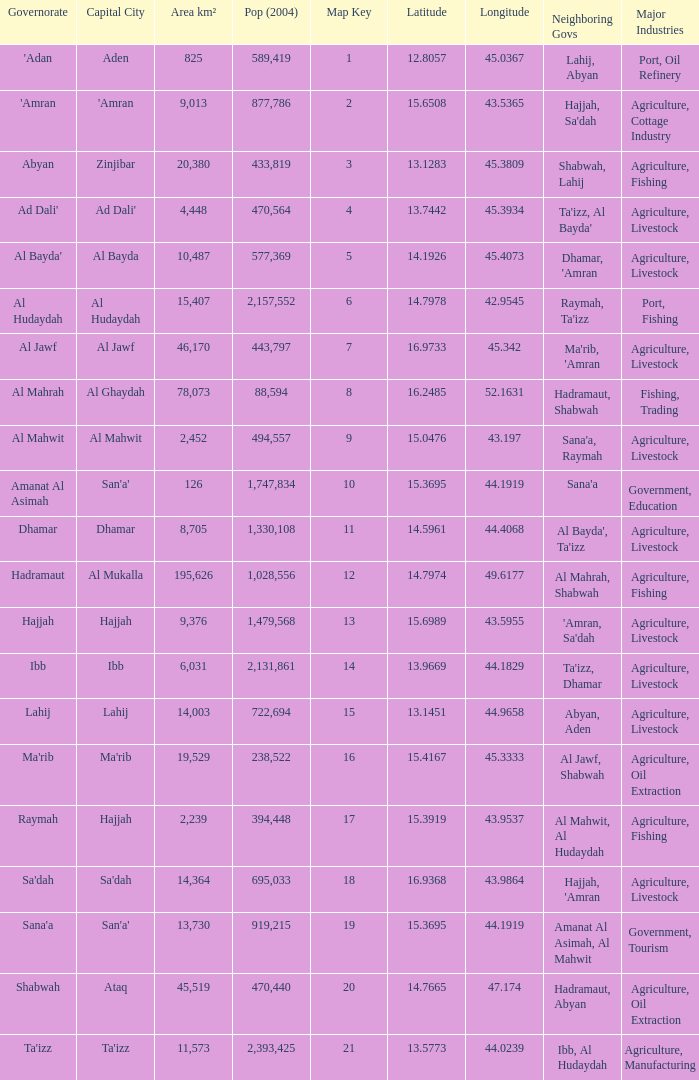Name the amount of Map Key which has a Pop (2004) smaller than 433,819, and a Capital City of hajjah, and an Area km² smaller than 9,376? Question 1 17.0. 